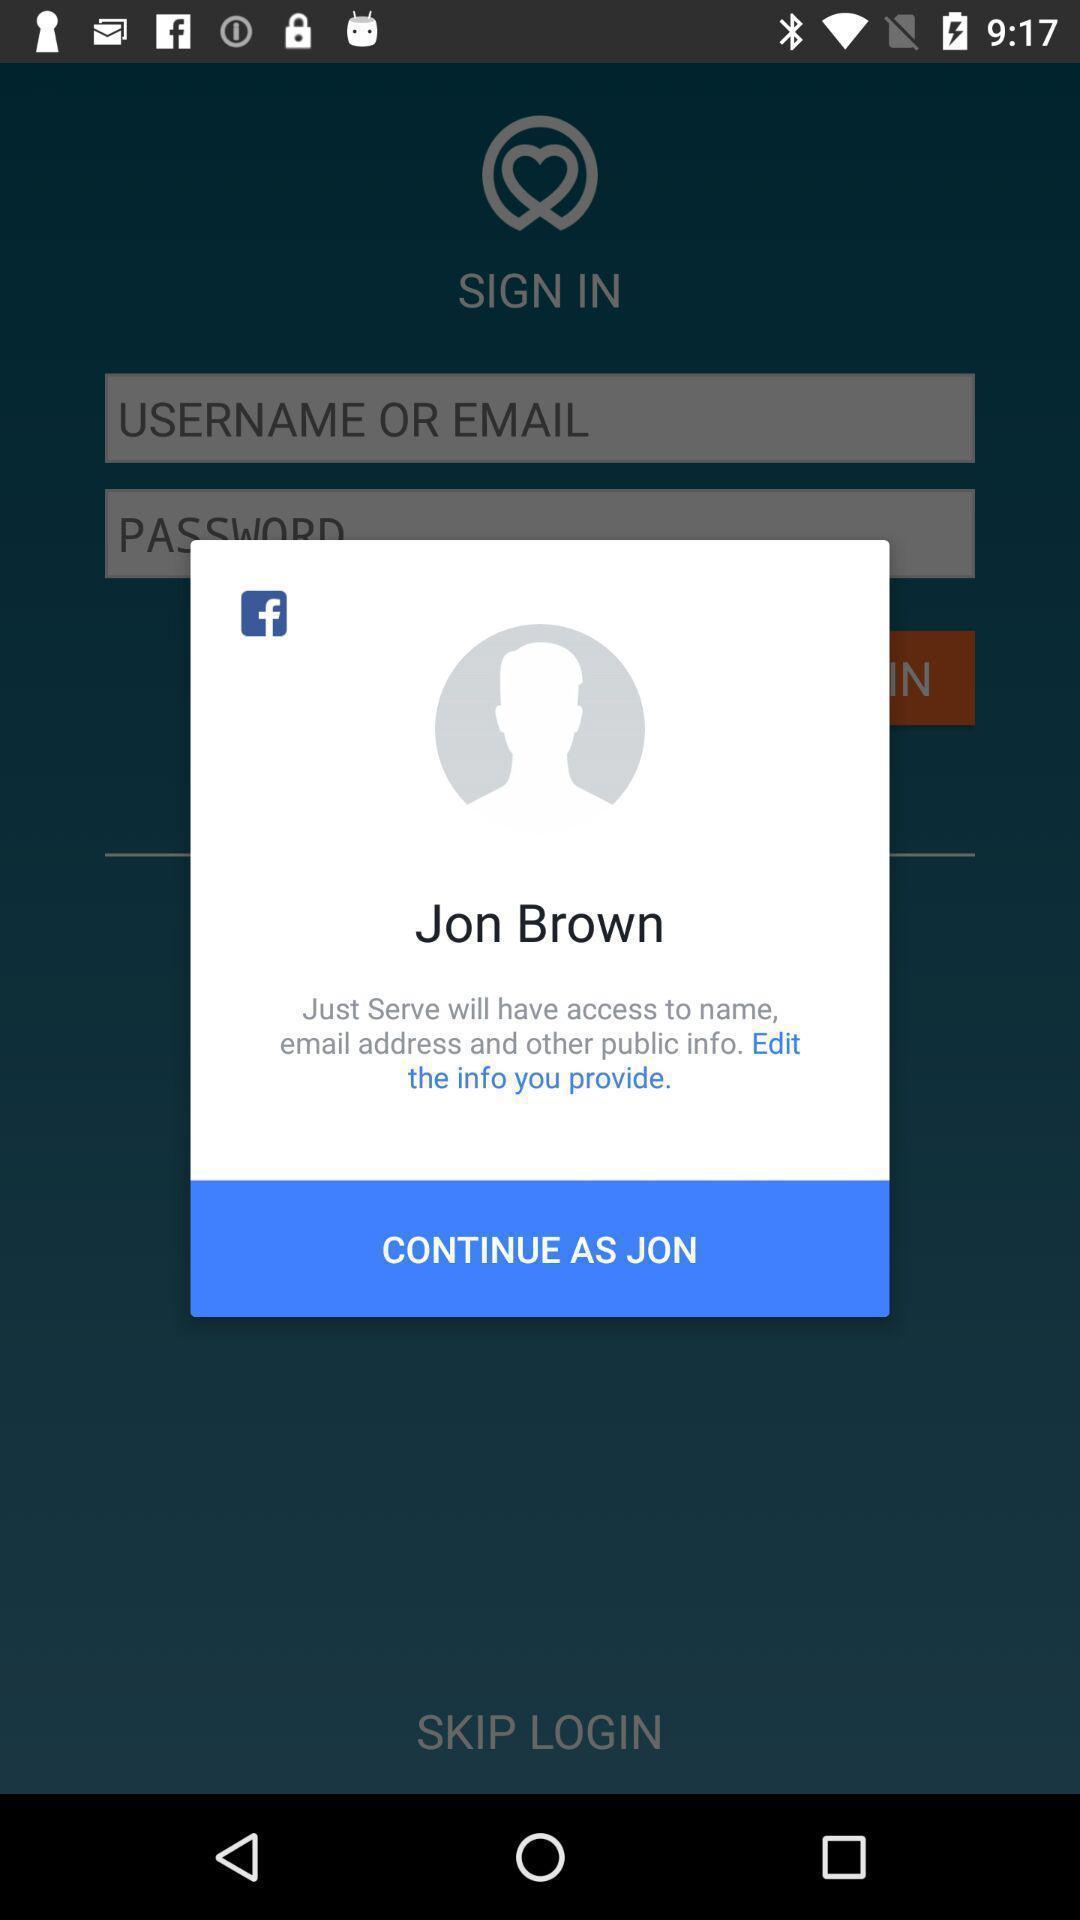Tell me about the visual elements in this screen capture. Pop-up showing an option to edit the profile. 